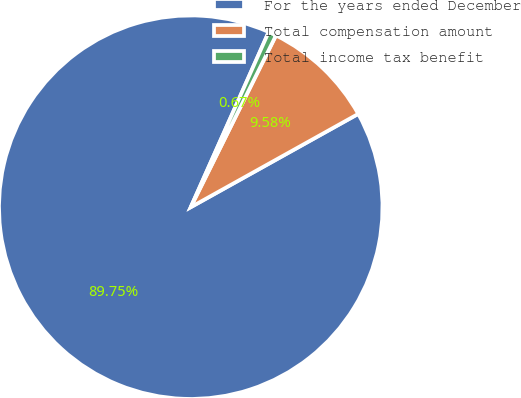Convert chart to OTSL. <chart><loc_0><loc_0><loc_500><loc_500><pie_chart><fcel>For the years ended December<fcel>Total compensation amount<fcel>Total income tax benefit<nl><fcel>89.75%<fcel>9.58%<fcel>0.67%<nl></chart> 